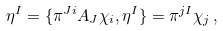Convert formula to latex. <formula><loc_0><loc_0><loc_500><loc_500>\eta ^ { I } = \{ { \pi } ^ { J i } A _ { J } { \chi } _ { i } , \eta ^ { I } \} = \pi ^ { j I } \chi _ { j } \, ,</formula> 